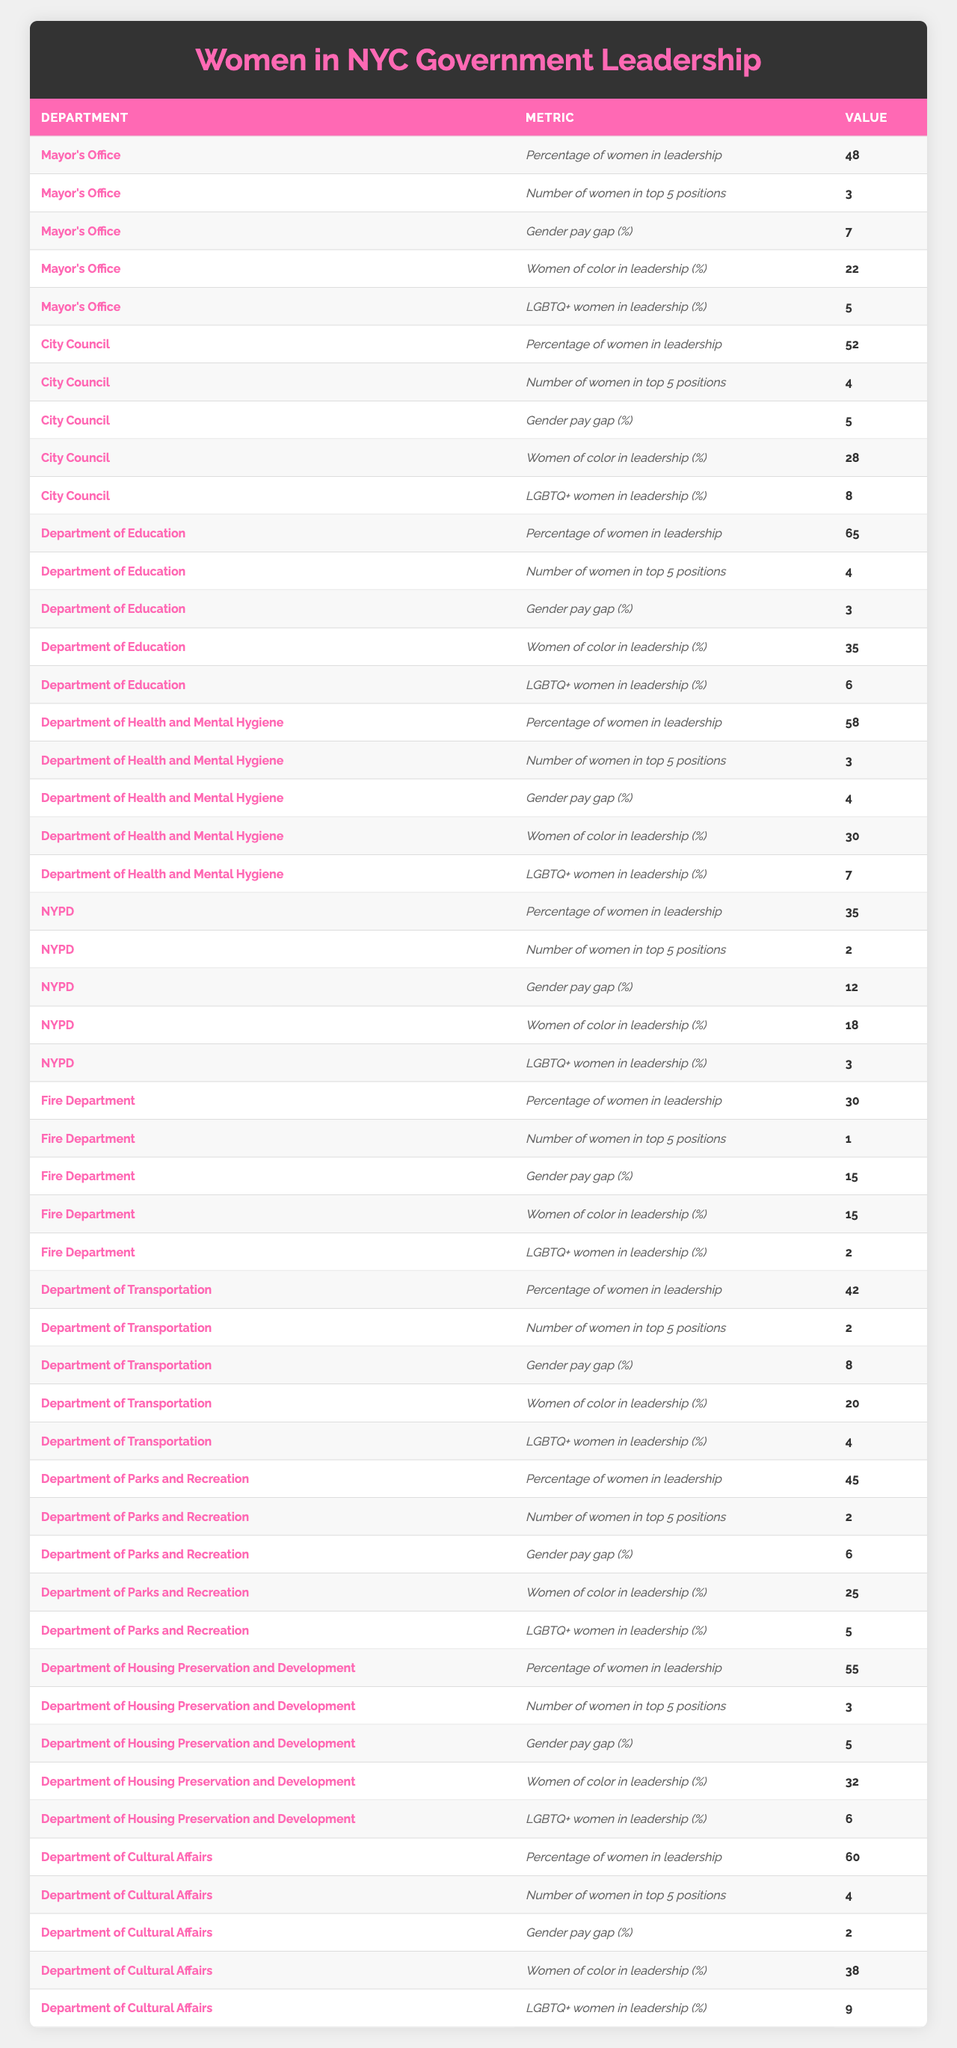What is the percentage of women in leadership in the Department of Education? Referring to the table, the value for the "Percentage of women in leadership" for the Department of Education is 65%.
Answer: 65% Which department has the highest gender pay gap percentage? Upon reviewing the table, the department with the highest gender pay gap percentage is the Fire Department at 15%.
Answer: 15% What is the total number of women in the top 5 positions across all departments? Adding the number of women in top 5 positions from each department: 3 (Mayor's Office) + 4 (City Council) + 4 (Department of Education) + 3 (Department of Health and Mental Hygiene) + 2 (NYPD) + 1 (Fire Department) + 2 (Department of Transportation) + 2 (Department of Parks and Recreation) + 3 (Department of Housing Preservation and Development) + 4 (Department of Cultural Affairs) = 28.
Answer: 28 Are there more than 30% women of color in leadership positions within the Department of Health and Mental Hygiene? The table shows that 30% of the leadership positions in the Department of Health and Mental Hygiene are occupied by women of color. Since the question asks if it's more than 30%, the answer is no.
Answer: No Which department has the highest representation of LGBTQ+ women in leadership positions? The Department of Cultural Affairs has the highest representation of LGBTQ+ women in leadership at 9%.
Answer: 9% What is the average percentage of women in leadership across all departments? The percentages for all departments are: 48, 52, 65, 58, 35, 30, 42, 45, 55, 60. Adding these gives 48 + 52 + 65 + 58 + 35 + 30 + 42 + 45 + 55 + 60 = 490. Divide by the number of departments (10): 490 / 10 = 49.
Answer: 49 Is it true that the NYPD has more women in leadership positions than the Fire Department? The percentage of women in leadership in the NYPD is 35%, while in the Fire Department it is 30%. Since 35% is greater than 30%, the statement is true.
Answer: Yes What is the difference in the percentage of women in leadership between the City Council and the NYPD? The percentage of women in leadership in the City Council is 52%, and in the NYPD it is 35%. The difference is 52 - 35 = 17%.
Answer: 17 Which department has the lowest percentage of women in leadership positions? According to the table, the Fire Department has the lowest percentage of women in leadership at 30%.
Answer: 30% What percentage of women in leadership positions are women of color in the Department of Transportation? The table indicates that women of color in leadership positions in the Department of Transportation is 20%.
Answer: 20% What is the median percentage of women in leadership across all departments? The percentages for women in leadership are: 30, 35, 42, 45, 48, 52, 55, 58, 60, 65. When ordered, the median is the average of the 5th (48) and the 6th (52) values. Therefore, (48 + 52) / 2 = 50.
Answer: 50 